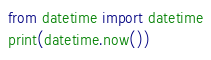<code> <loc_0><loc_0><loc_500><loc_500><_Python_>from datetime import datetime
print(datetime.now())
</code> 